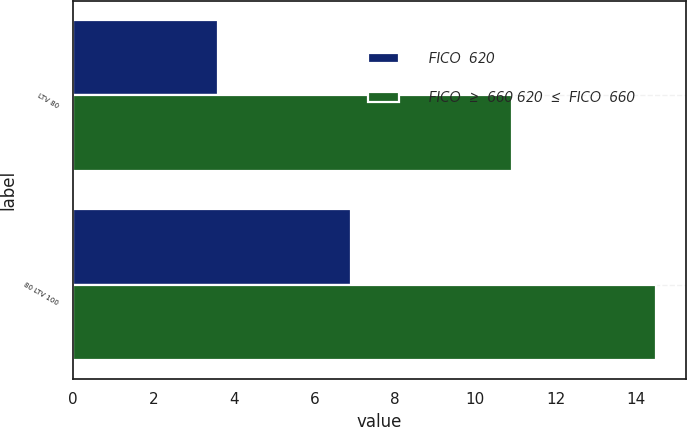<chart> <loc_0><loc_0><loc_500><loc_500><stacked_bar_chart><ecel><fcel>LTV 80<fcel>80 LTV 100<nl><fcel>FICO  620<fcel>3.6<fcel>6.9<nl><fcel>FICO  ≥  660 620  ≤  FICO  660<fcel>10.9<fcel>14.5<nl></chart> 